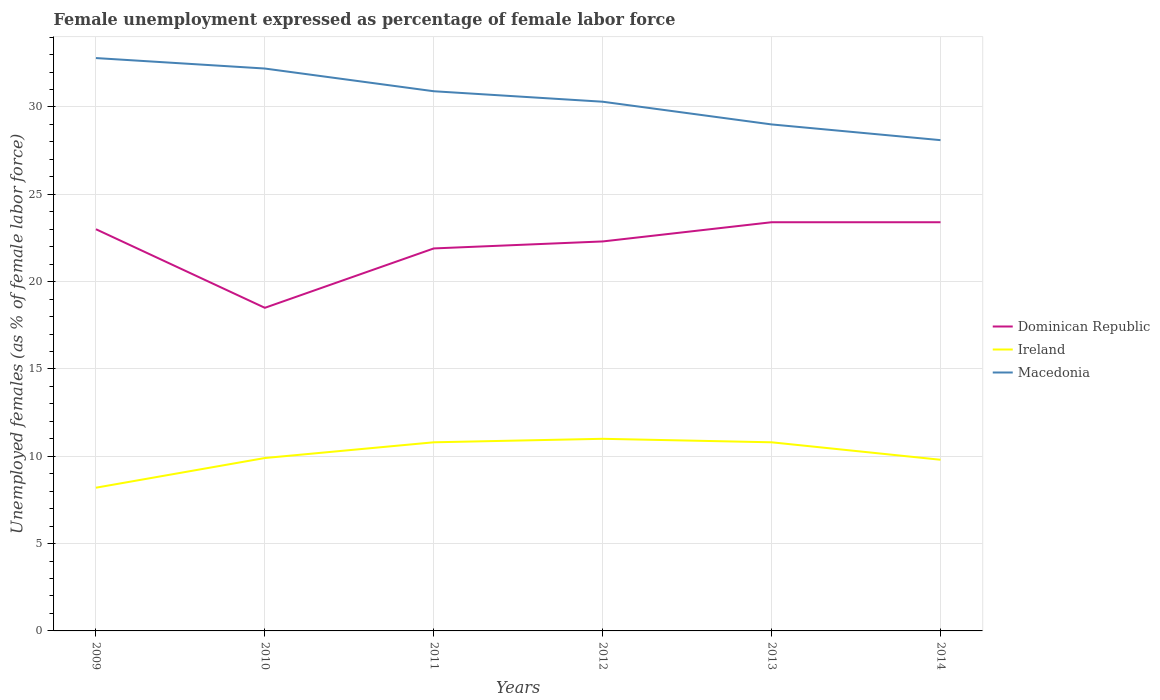Does the line corresponding to Dominican Republic intersect with the line corresponding to Macedonia?
Offer a terse response. No. Across all years, what is the maximum unemployment in females in in Ireland?
Provide a short and direct response. 8.2. What is the total unemployment in females in in Dominican Republic in the graph?
Provide a succinct answer. -0.4. What is the difference between the highest and the second highest unemployment in females in in Macedonia?
Provide a succinct answer. 4.7. What is the difference between the highest and the lowest unemployment in females in in Dominican Republic?
Give a very brief answer. 4. Is the unemployment in females in in Dominican Republic strictly greater than the unemployment in females in in Ireland over the years?
Make the answer very short. No. How many lines are there?
Provide a succinct answer. 3. How many years are there in the graph?
Keep it short and to the point. 6. How many legend labels are there?
Offer a terse response. 3. How are the legend labels stacked?
Provide a short and direct response. Vertical. What is the title of the graph?
Give a very brief answer. Female unemployment expressed as percentage of female labor force. What is the label or title of the X-axis?
Your answer should be compact. Years. What is the label or title of the Y-axis?
Give a very brief answer. Unemployed females (as % of female labor force). What is the Unemployed females (as % of female labor force) of Dominican Republic in 2009?
Provide a succinct answer. 23. What is the Unemployed females (as % of female labor force) in Ireland in 2009?
Provide a short and direct response. 8.2. What is the Unemployed females (as % of female labor force) of Macedonia in 2009?
Provide a short and direct response. 32.8. What is the Unemployed females (as % of female labor force) in Ireland in 2010?
Offer a terse response. 9.9. What is the Unemployed females (as % of female labor force) of Macedonia in 2010?
Your answer should be very brief. 32.2. What is the Unemployed females (as % of female labor force) of Dominican Republic in 2011?
Make the answer very short. 21.9. What is the Unemployed females (as % of female labor force) of Ireland in 2011?
Keep it short and to the point. 10.8. What is the Unemployed females (as % of female labor force) of Macedonia in 2011?
Make the answer very short. 30.9. What is the Unemployed females (as % of female labor force) of Dominican Republic in 2012?
Keep it short and to the point. 22.3. What is the Unemployed females (as % of female labor force) in Macedonia in 2012?
Keep it short and to the point. 30.3. What is the Unemployed females (as % of female labor force) of Dominican Republic in 2013?
Keep it short and to the point. 23.4. What is the Unemployed females (as % of female labor force) in Ireland in 2013?
Your answer should be compact. 10.8. What is the Unemployed females (as % of female labor force) of Macedonia in 2013?
Ensure brevity in your answer.  29. What is the Unemployed females (as % of female labor force) in Dominican Republic in 2014?
Offer a very short reply. 23.4. What is the Unemployed females (as % of female labor force) in Ireland in 2014?
Provide a succinct answer. 9.8. What is the Unemployed females (as % of female labor force) of Macedonia in 2014?
Give a very brief answer. 28.1. Across all years, what is the maximum Unemployed females (as % of female labor force) of Dominican Republic?
Provide a short and direct response. 23.4. Across all years, what is the maximum Unemployed females (as % of female labor force) of Macedonia?
Ensure brevity in your answer.  32.8. Across all years, what is the minimum Unemployed females (as % of female labor force) of Dominican Republic?
Provide a succinct answer. 18.5. Across all years, what is the minimum Unemployed females (as % of female labor force) of Ireland?
Your answer should be very brief. 8.2. Across all years, what is the minimum Unemployed females (as % of female labor force) in Macedonia?
Offer a terse response. 28.1. What is the total Unemployed females (as % of female labor force) of Dominican Republic in the graph?
Your response must be concise. 132.5. What is the total Unemployed females (as % of female labor force) of Ireland in the graph?
Give a very brief answer. 60.5. What is the total Unemployed females (as % of female labor force) in Macedonia in the graph?
Your response must be concise. 183.3. What is the difference between the Unemployed females (as % of female labor force) in Dominican Republic in 2009 and that in 2010?
Your answer should be very brief. 4.5. What is the difference between the Unemployed females (as % of female labor force) of Macedonia in 2009 and that in 2010?
Offer a very short reply. 0.6. What is the difference between the Unemployed females (as % of female labor force) in Ireland in 2009 and that in 2011?
Provide a short and direct response. -2.6. What is the difference between the Unemployed females (as % of female labor force) in Dominican Republic in 2009 and that in 2012?
Keep it short and to the point. 0.7. What is the difference between the Unemployed females (as % of female labor force) in Dominican Republic in 2009 and that in 2013?
Provide a short and direct response. -0.4. What is the difference between the Unemployed females (as % of female labor force) in Dominican Republic in 2010 and that in 2011?
Make the answer very short. -3.4. What is the difference between the Unemployed females (as % of female labor force) in Macedonia in 2010 and that in 2011?
Provide a short and direct response. 1.3. What is the difference between the Unemployed females (as % of female labor force) in Dominican Republic in 2010 and that in 2012?
Make the answer very short. -3.8. What is the difference between the Unemployed females (as % of female labor force) of Ireland in 2010 and that in 2012?
Ensure brevity in your answer.  -1.1. What is the difference between the Unemployed females (as % of female labor force) of Dominican Republic in 2010 and that in 2013?
Offer a very short reply. -4.9. What is the difference between the Unemployed females (as % of female labor force) in Ireland in 2010 and that in 2013?
Your answer should be very brief. -0.9. What is the difference between the Unemployed females (as % of female labor force) of Ireland in 2010 and that in 2014?
Your answer should be very brief. 0.1. What is the difference between the Unemployed females (as % of female labor force) in Macedonia in 2011 and that in 2012?
Provide a succinct answer. 0.6. What is the difference between the Unemployed females (as % of female labor force) in Dominican Republic in 2011 and that in 2013?
Provide a succinct answer. -1.5. What is the difference between the Unemployed females (as % of female labor force) in Ireland in 2011 and that in 2013?
Offer a very short reply. 0. What is the difference between the Unemployed females (as % of female labor force) in Ireland in 2012 and that in 2013?
Keep it short and to the point. 0.2. What is the difference between the Unemployed females (as % of female labor force) of Macedonia in 2012 and that in 2013?
Your answer should be very brief. 1.3. What is the difference between the Unemployed females (as % of female labor force) in Dominican Republic in 2012 and that in 2014?
Provide a short and direct response. -1.1. What is the difference between the Unemployed females (as % of female labor force) of Macedonia in 2012 and that in 2014?
Give a very brief answer. 2.2. What is the difference between the Unemployed females (as % of female labor force) in Dominican Republic in 2013 and that in 2014?
Ensure brevity in your answer.  0. What is the difference between the Unemployed females (as % of female labor force) in Dominican Republic in 2009 and the Unemployed females (as % of female labor force) in Ireland in 2010?
Provide a short and direct response. 13.1. What is the difference between the Unemployed females (as % of female labor force) in Dominican Republic in 2009 and the Unemployed females (as % of female labor force) in Macedonia in 2010?
Give a very brief answer. -9.2. What is the difference between the Unemployed females (as % of female labor force) of Ireland in 2009 and the Unemployed females (as % of female labor force) of Macedonia in 2010?
Offer a very short reply. -24. What is the difference between the Unemployed females (as % of female labor force) of Dominican Republic in 2009 and the Unemployed females (as % of female labor force) of Ireland in 2011?
Give a very brief answer. 12.2. What is the difference between the Unemployed females (as % of female labor force) of Ireland in 2009 and the Unemployed females (as % of female labor force) of Macedonia in 2011?
Offer a terse response. -22.7. What is the difference between the Unemployed females (as % of female labor force) in Dominican Republic in 2009 and the Unemployed females (as % of female labor force) in Macedonia in 2012?
Give a very brief answer. -7.3. What is the difference between the Unemployed females (as % of female labor force) in Ireland in 2009 and the Unemployed females (as % of female labor force) in Macedonia in 2012?
Offer a terse response. -22.1. What is the difference between the Unemployed females (as % of female labor force) in Dominican Republic in 2009 and the Unemployed females (as % of female labor force) in Ireland in 2013?
Offer a terse response. 12.2. What is the difference between the Unemployed females (as % of female labor force) of Ireland in 2009 and the Unemployed females (as % of female labor force) of Macedonia in 2013?
Provide a short and direct response. -20.8. What is the difference between the Unemployed females (as % of female labor force) in Dominican Republic in 2009 and the Unemployed females (as % of female labor force) in Macedonia in 2014?
Ensure brevity in your answer.  -5.1. What is the difference between the Unemployed females (as % of female labor force) in Ireland in 2009 and the Unemployed females (as % of female labor force) in Macedonia in 2014?
Your response must be concise. -19.9. What is the difference between the Unemployed females (as % of female labor force) in Dominican Republic in 2010 and the Unemployed females (as % of female labor force) in Ireland in 2011?
Your answer should be compact. 7.7. What is the difference between the Unemployed females (as % of female labor force) in Dominican Republic in 2010 and the Unemployed females (as % of female labor force) in Macedonia in 2011?
Offer a terse response. -12.4. What is the difference between the Unemployed females (as % of female labor force) in Dominican Republic in 2010 and the Unemployed females (as % of female labor force) in Ireland in 2012?
Your answer should be very brief. 7.5. What is the difference between the Unemployed females (as % of female labor force) of Ireland in 2010 and the Unemployed females (as % of female labor force) of Macedonia in 2012?
Make the answer very short. -20.4. What is the difference between the Unemployed females (as % of female labor force) of Dominican Republic in 2010 and the Unemployed females (as % of female labor force) of Ireland in 2013?
Provide a short and direct response. 7.7. What is the difference between the Unemployed females (as % of female labor force) of Dominican Republic in 2010 and the Unemployed females (as % of female labor force) of Macedonia in 2013?
Provide a succinct answer. -10.5. What is the difference between the Unemployed females (as % of female labor force) in Ireland in 2010 and the Unemployed females (as % of female labor force) in Macedonia in 2013?
Ensure brevity in your answer.  -19.1. What is the difference between the Unemployed females (as % of female labor force) in Dominican Republic in 2010 and the Unemployed females (as % of female labor force) in Ireland in 2014?
Ensure brevity in your answer.  8.7. What is the difference between the Unemployed females (as % of female labor force) in Dominican Republic in 2010 and the Unemployed females (as % of female labor force) in Macedonia in 2014?
Your answer should be compact. -9.6. What is the difference between the Unemployed females (as % of female labor force) in Ireland in 2010 and the Unemployed females (as % of female labor force) in Macedonia in 2014?
Make the answer very short. -18.2. What is the difference between the Unemployed females (as % of female labor force) of Dominican Republic in 2011 and the Unemployed females (as % of female labor force) of Ireland in 2012?
Give a very brief answer. 10.9. What is the difference between the Unemployed females (as % of female labor force) of Ireland in 2011 and the Unemployed females (as % of female labor force) of Macedonia in 2012?
Offer a terse response. -19.5. What is the difference between the Unemployed females (as % of female labor force) of Ireland in 2011 and the Unemployed females (as % of female labor force) of Macedonia in 2013?
Offer a terse response. -18.2. What is the difference between the Unemployed females (as % of female labor force) of Dominican Republic in 2011 and the Unemployed females (as % of female labor force) of Ireland in 2014?
Offer a very short reply. 12.1. What is the difference between the Unemployed females (as % of female labor force) of Ireland in 2011 and the Unemployed females (as % of female labor force) of Macedonia in 2014?
Provide a succinct answer. -17.3. What is the difference between the Unemployed females (as % of female labor force) in Dominican Republic in 2012 and the Unemployed females (as % of female labor force) in Ireland in 2013?
Provide a short and direct response. 11.5. What is the difference between the Unemployed females (as % of female labor force) in Ireland in 2012 and the Unemployed females (as % of female labor force) in Macedonia in 2013?
Offer a terse response. -18. What is the difference between the Unemployed females (as % of female labor force) of Dominican Republic in 2012 and the Unemployed females (as % of female labor force) of Ireland in 2014?
Offer a very short reply. 12.5. What is the difference between the Unemployed females (as % of female labor force) in Dominican Republic in 2012 and the Unemployed females (as % of female labor force) in Macedonia in 2014?
Offer a very short reply. -5.8. What is the difference between the Unemployed females (as % of female labor force) in Ireland in 2012 and the Unemployed females (as % of female labor force) in Macedonia in 2014?
Provide a succinct answer. -17.1. What is the difference between the Unemployed females (as % of female labor force) of Dominican Republic in 2013 and the Unemployed females (as % of female labor force) of Ireland in 2014?
Offer a terse response. 13.6. What is the difference between the Unemployed females (as % of female labor force) of Dominican Republic in 2013 and the Unemployed females (as % of female labor force) of Macedonia in 2014?
Make the answer very short. -4.7. What is the difference between the Unemployed females (as % of female labor force) in Ireland in 2013 and the Unemployed females (as % of female labor force) in Macedonia in 2014?
Ensure brevity in your answer.  -17.3. What is the average Unemployed females (as % of female labor force) of Dominican Republic per year?
Ensure brevity in your answer.  22.08. What is the average Unemployed females (as % of female labor force) of Ireland per year?
Your answer should be compact. 10.08. What is the average Unemployed females (as % of female labor force) of Macedonia per year?
Give a very brief answer. 30.55. In the year 2009, what is the difference between the Unemployed females (as % of female labor force) of Dominican Republic and Unemployed females (as % of female labor force) of Ireland?
Keep it short and to the point. 14.8. In the year 2009, what is the difference between the Unemployed females (as % of female labor force) of Dominican Republic and Unemployed females (as % of female labor force) of Macedonia?
Offer a terse response. -9.8. In the year 2009, what is the difference between the Unemployed females (as % of female labor force) of Ireland and Unemployed females (as % of female labor force) of Macedonia?
Make the answer very short. -24.6. In the year 2010, what is the difference between the Unemployed females (as % of female labor force) of Dominican Republic and Unemployed females (as % of female labor force) of Ireland?
Keep it short and to the point. 8.6. In the year 2010, what is the difference between the Unemployed females (as % of female labor force) of Dominican Republic and Unemployed females (as % of female labor force) of Macedonia?
Ensure brevity in your answer.  -13.7. In the year 2010, what is the difference between the Unemployed females (as % of female labor force) in Ireland and Unemployed females (as % of female labor force) in Macedonia?
Offer a terse response. -22.3. In the year 2011, what is the difference between the Unemployed females (as % of female labor force) of Dominican Republic and Unemployed females (as % of female labor force) of Ireland?
Your response must be concise. 11.1. In the year 2011, what is the difference between the Unemployed females (as % of female labor force) in Dominican Republic and Unemployed females (as % of female labor force) in Macedonia?
Your response must be concise. -9. In the year 2011, what is the difference between the Unemployed females (as % of female labor force) of Ireland and Unemployed females (as % of female labor force) of Macedonia?
Your response must be concise. -20.1. In the year 2012, what is the difference between the Unemployed females (as % of female labor force) of Dominican Republic and Unemployed females (as % of female labor force) of Macedonia?
Give a very brief answer. -8. In the year 2012, what is the difference between the Unemployed females (as % of female labor force) in Ireland and Unemployed females (as % of female labor force) in Macedonia?
Keep it short and to the point. -19.3. In the year 2013, what is the difference between the Unemployed females (as % of female labor force) of Dominican Republic and Unemployed females (as % of female labor force) of Macedonia?
Give a very brief answer. -5.6. In the year 2013, what is the difference between the Unemployed females (as % of female labor force) in Ireland and Unemployed females (as % of female labor force) in Macedonia?
Offer a terse response. -18.2. In the year 2014, what is the difference between the Unemployed females (as % of female labor force) of Dominican Republic and Unemployed females (as % of female labor force) of Ireland?
Keep it short and to the point. 13.6. In the year 2014, what is the difference between the Unemployed females (as % of female labor force) of Ireland and Unemployed females (as % of female labor force) of Macedonia?
Keep it short and to the point. -18.3. What is the ratio of the Unemployed females (as % of female labor force) of Dominican Republic in 2009 to that in 2010?
Offer a terse response. 1.24. What is the ratio of the Unemployed females (as % of female labor force) of Ireland in 2009 to that in 2010?
Make the answer very short. 0.83. What is the ratio of the Unemployed females (as % of female labor force) in Macedonia in 2009 to that in 2010?
Your response must be concise. 1.02. What is the ratio of the Unemployed females (as % of female labor force) of Dominican Republic in 2009 to that in 2011?
Your response must be concise. 1.05. What is the ratio of the Unemployed females (as % of female labor force) in Ireland in 2009 to that in 2011?
Offer a very short reply. 0.76. What is the ratio of the Unemployed females (as % of female labor force) of Macedonia in 2009 to that in 2011?
Give a very brief answer. 1.06. What is the ratio of the Unemployed females (as % of female labor force) in Dominican Republic in 2009 to that in 2012?
Ensure brevity in your answer.  1.03. What is the ratio of the Unemployed females (as % of female labor force) in Ireland in 2009 to that in 2012?
Offer a terse response. 0.75. What is the ratio of the Unemployed females (as % of female labor force) of Macedonia in 2009 to that in 2012?
Provide a short and direct response. 1.08. What is the ratio of the Unemployed females (as % of female labor force) of Dominican Republic in 2009 to that in 2013?
Offer a very short reply. 0.98. What is the ratio of the Unemployed females (as % of female labor force) of Ireland in 2009 to that in 2013?
Your response must be concise. 0.76. What is the ratio of the Unemployed females (as % of female labor force) in Macedonia in 2009 to that in 2013?
Provide a short and direct response. 1.13. What is the ratio of the Unemployed females (as % of female labor force) in Dominican Republic in 2009 to that in 2014?
Give a very brief answer. 0.98. What is the ratio of the Unemployed females (as % of female labor force) of Ireland in 2009 to that in 2014?
Give a very brief answer. 0.84. What is the ratio of the Unemployed females (as % of female labor force) in Macedonia in 2009 to that in 2014?
Offer a terse response. 1.17. What is the ratio of the Unemployed females (as % of female labor force) of Dominican Republic in 2010 to that in 2011?
Offer a very short reply. 0.84. What is the ratio of the Unemployed females (as % of female labor force) of Ireland in 2010 to that in 2011?
Ensure brevity in your answer.  0.92. What is the ratio of the Unemployed females (as % of female labor force) in Macedonia in 2010 to that in 2011?
Offer a very short reply. 1.04. What is the ratio of the Unemployed females (as % of female labor force) of Dominican Republic in 2010 to that in 2012?
Provide a succinct answer. 0.83. What is the ratio of the Unemployed females (as % of female labor force) in Macedonia in 2010 to that in 2012?
Keep it short and to the point. 1.06. What is the ratio of the Unemployed females (as % of female labor force) of Dominican Republic in 2010 to that in 2013?
Offer a very short reply. 0.79. What is the ratio of the Unemployed females (as % of female labor force) of Macedonia in 2010 to that in 2013?
Offer a terse response. 1.11. What is the ratio of the Unemployed females (as % of female labor force) of Dominican Republic in 2010 to that in 2014?
Offer a very short reply. 0.79. What is the ratio of the Unemployed females (as % of female labor force) in Ireland in 2010 to that in 2014?
Give a very brief answer. 1.01. What is the ratio of the Unemployed females (as % of female labor force) of Macedonia in 2010 to that in 2014?
Your answer should be compact. 1.15. What is the ratio of the Unemployed females (as % of female labor force) in Dominican Republic in 2011 to that in 2012?
Offer a terse response. 0.98. What is the ratio of the Unemployed females (as % of female labor force) in Ireland in 2011 to that in 2012?
Keep it short and to the point. 0.98. What is the ratio of the Unemployed females (as % of female labor force) in Macedonia in 2011 to that in 2012?
Provide a short and direct response. 1.02. What is the ratio of the Unemployed females (as % of female labor force) of Dominican Republic in 2011 to that in 2013?
Your answer should be compact. 0.94. What is the ratio of the Unemployed females (as % of female labor force) of Ireland in 2011 to that in 2013?
Your response must be concise. 1. What is the ratio of the Unemployed females (as % of female labor force) in Macedonia in 2011 to that in 2013?
Offer a terse response. 1.07. What is the ratio of the Unemployed females (as % of female labor force) in Dominican Republic in 2011 to that in 2014?
Provide a succinct answer. 0.94. What is the ratio of the Unemployed females (as % of female labor force) of Ireland in 2011 to that in 2014?
Keep it short and to the point. 1.1. What is the ratio of the Unemployed females (as % of female labor force) in Macedonia in 2011 to that in 2014?
Your answer should be very brief. 1.1. What is the ratio of the Unemployed females (as % of female labor force) of Dominican Republic in 2012 to that in 2013?
Offer a terse response. 0.95. What is the ratio of the Unemployed females (as % of female labor force) in Ireland in 2012 to that in 2013?
Your answer should be very brief. 1.02. What is the ratio of the Unemployed females (as % of female labor force) of Macedonia in 2012 to that in 2013?
Offer a terse response. 1.04. What is the ratio of the Unemployed females (as % of female labor force) of Dominican Republic in 2012 to that in 2014?
Keep it short and to the point. 0.95. What is the ratio of the Unemployed females (as % of female labor force) of Ireland in 2012 to that in 2014?
Ensure brevity in your answer.  1.12. What is the ratio of the Unemployed females (as % of female labor force) in Macedonia in 2012 to that in 2014?
Make the answer very short. 1.08. What is the ratio of the Unemployed females (as % of female labor force) in Dominican Republic in 2013 to that in 2014?
Your answer should be very brief. 1. What is the ratio of the Unemployed females (as % of female labor force) of Ireland in 2013 to that in 2014?
Ensure brevity in your answer.  1.1. What is the ratio of the Unemployed females (as % of female labor force) of Macedonia in 2013 to that in 2014?
Ensure brevity in your answer.  1.03. What is the difference between the highest and the second highest Unemployed females (as % of female labor force) in Ireland?
Your response must be concise. 0.2. What is the difference between the highest and the second highest Unemployed females (as % of female labor force) of Macedonia?
Keep it short and to the point. 0.6. What is the difference between the highest and the lowest Unemployed females (as % of female labor force) in Macedonia?
Ensure brevity in your answer.  4.7. 